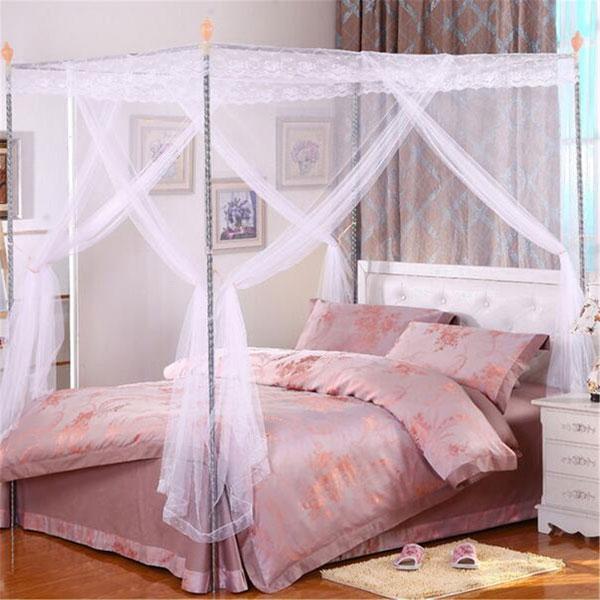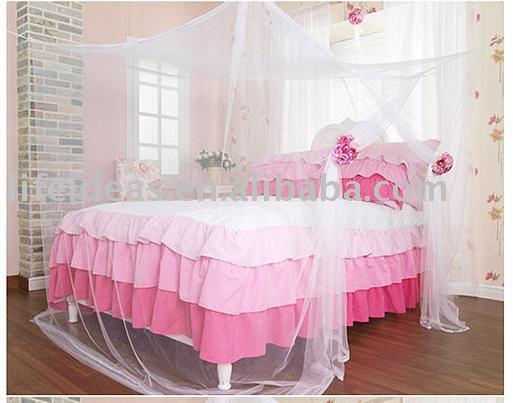The first image is the image on the left, the second image is the image on the right. Considering the images on both sides, is "The bed on the left has a canopy that ties at the middle of the four posts, and the bed on the right has a pale canopy that creates a square shape but does not tie at the corners." valid? Answer yes or no. Yes. The first image is the image on the left, the second image is the image on the right. Given the left and right images, does the statement "The left and right image contains the same number of square lace canopies." hold true? Answer yes or no. Yes. 